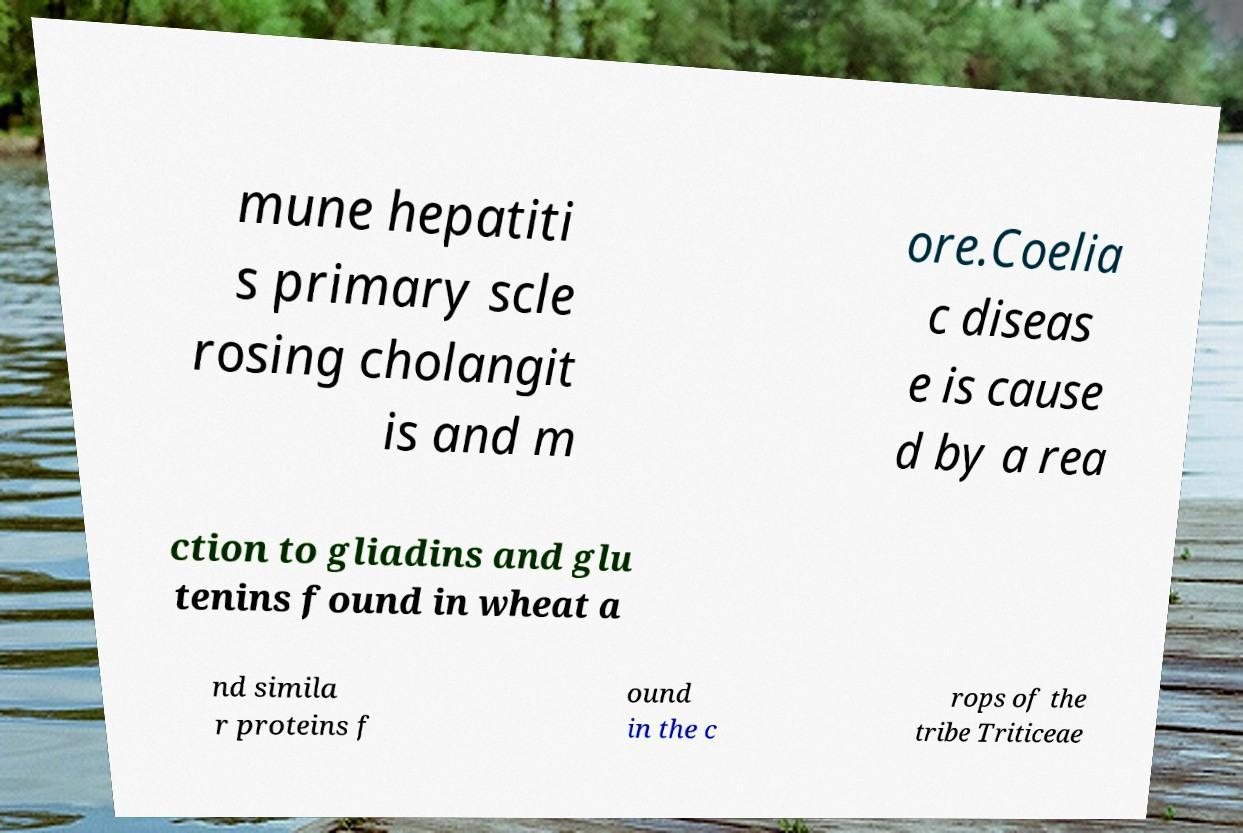Please identify and transcribe the text found in this image. mune hepatiti s primary scle rosing cholangit is and m ore.Coelia c diseas e is cause d by a rea ction to gliadins and glu tenins found in wheat a nd simila r proteins f ound in the c rops of the tribe Triticeae 